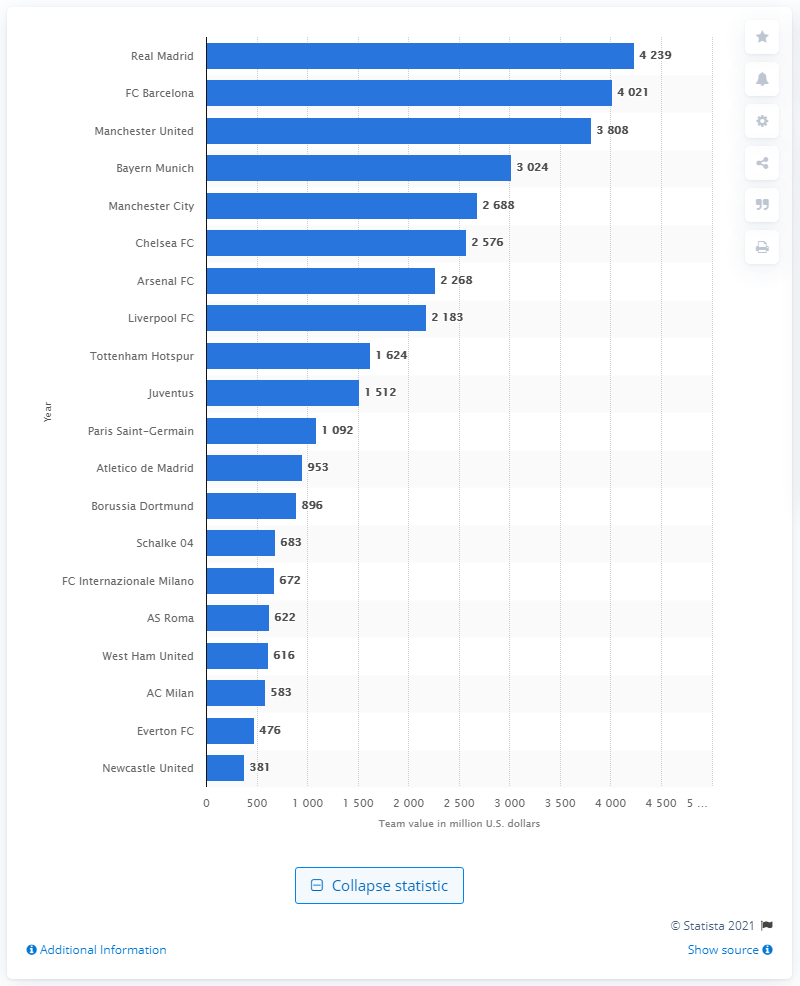Point out several critical features in this image. According to Forbes, Real Madrid is the most valuable soccer/football team in the world. In 2019, the estimated value of Real Madrid in dollars was 4,239. 